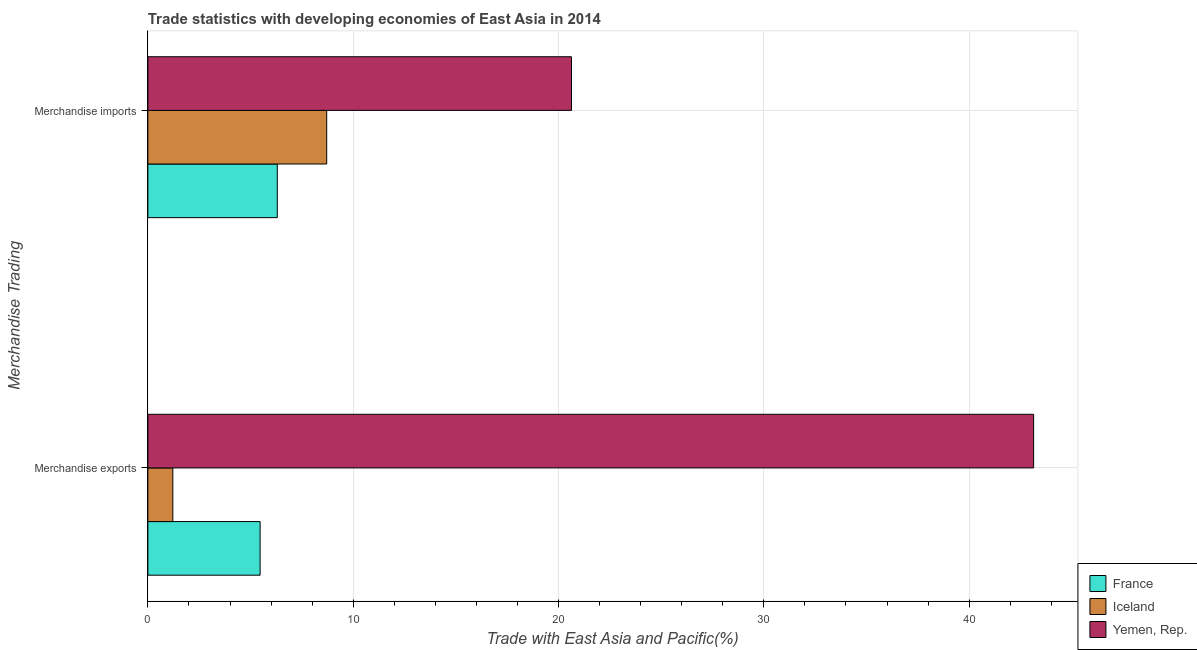Are the number of bars on each tick of the Y-axis equal?
Offer a terse response. Yes. How many bars are there on the 2nd tick from the top?
Give a very brief answer. 3. What is the merchandise imports in France?
Your answer should be compact. 6.3. Across all countries, what is the maximum merchandise imports?
Give a very brief answer. 20.63. Across all countries, what is the minimum merchandise exports?
Your answer should be very brief. 1.21. In which country was the merchandise imports maximum?
Give a very brief answer. Yemen, Rep. What is the total merchandise imports in the graph?
Offer a very short reply. 35.64. What is the difference between the merchandise imports in France and that in Yemen, Rep.?
Your answer should be compact. -14.33. What is the difference between the merchandise imports in France and the merchandise exports in Yemen, Rep.?
Your answer should be compact. -36.84. What is the average merchandise imports per country?
Your answer should be compact. 11.88. What is the difference between the merchandise exports and merchandise imports in Iceland?
Give a very brief answer. -7.49. What is the ratio of the merchandise exports in France to that in Yemen, Rep.?
Your answer should be very brief. 0.13. Is the merchandise imports in France less than that in Yemen, Rep.?
Make the answer very short. Yes. In how many countries, is the merchandise imports greater than the average merchandise imports taken over all countries?
Your answer should be compact. 1. What does the 1st bar from the top in Merchandise imports represents?
Offer a terse response. Yemen, Rep. What does the 2nd bar from the bottom in Merchandise imports represents?
Your answer should be compact. Iceland. How many countries are there in the graph?
Keep it short and to the point. 3. Where does the legend appear in the graph?
Provide a succinct answer. Bottom right. How are the legend labels stacked?
Your answer should be compact. Vertical. What is the title of the graph?
Provide a short and direct response. Trade statistics with developing economies of East Asia in 2014. Does "Grenada" appear as one of the legend labels in the graph?
Offer a terse response. No. What is the label or title of the X-axis?
Give a very brief answer. Trade with East Asia and Pacific(%). What is the label or title of the Y-axis?
Provide a short and direct response. Merchandise Trading. What is the Trade with East Asia and Pacific(%) of France in Merchandise exports?
Your response must be concise. 5.47. What is the Trade with East Asia and Pacific(%) in Iceland in Merchandise exports?
Your answer should be very brief. 1.21. What is the Trade with East Asia and Pacific(%) in Yemen, Rep. in Merchandise exports?
Provide a succinct answer. 43.14. What is the Trade with East Asia and Pacific(%) in France in Merchandise imports?
Your answer should be very brief. 6.3. What is the Trade with East Asia and Pacific(%) in Iceland in Merchandise imports?
Your answer should be compact. 8.71. What is the Trade with East Asia and Pacific(%) in Yemen, Rep. in Merchandise imports?
Provide a short and direct response. 20.63. Across all Merchandise Trading, what is the maximum Trade with East Asia and Pacific(%) of France?
Offer a terse response. 6.3. Across all Merchandise Trading, what is the maximum Trade with East Asia and Pacific(%) in Iceland?
Ensure brevity in your answer.  8.71. Across all Merchandise Trading, what is the maximum Trade with East Asia and Pacific(%) in Yemen, Rep.?
Provide a succinct answer. 43.14. Across all Merchandise Trading, what is the minimum Trade with East Asia and Pacific(%) in France?
Ensure brevity in your answer.  5.47. Across all Merchandise Trading, what is the minimum Trade with East Asia and Pacific(%) in Iceland?
Ensure brevity in your answer.  1.21. Across all Merchandise Trading, what is the minimum Trade with East Asia and Pacific(%) of Yemen, Rep.?
Offer a terse response. 20.63. What is the total Trade with East Asia and Pacific(%) in France in the graph?
Your answer should be very brief. 11.77. What is the total Trade with East Asia and Pacific(%) in Iceland in the graph?
Your response must be concise. 9.92. What is the total Trade with East Asia and Pacific(%) of Yemen, Rep. in the graph?
Your answer should be compact. 63.77. What is the difference between the Trade with East Asia and Pacific(%) in France in Merchandise exports and that in Merchandise imports?
Ensure brevity in your answer.  -0.84. What is the difference between the Trade with East Asia and Pacific(%) of Iceland in Merchandise exports and that in Merchandise imports?
Your answer should be very brief. -7.49. What is the difference between the Trade with East Asia and Pacific(%) in Yemen, Rep. in Merchandise exports and that in Merchandise imports?
Your answer should be compact. 22.51. What is the difference between the Trade with East Asia and Pacific(%) of France in Merchandise exports and the Trade with East Asia and Pacific(%) of Iceland in Merchandise imports?
Your answer should be very brief. -3.24. What is the difference between the Trade with East Asia and Pacific(%) in France in Merchandise exports and the Trade with East Asia and Pacific(%) in Yemen, Rep. in Merchandise imports?
Your response must be concise. -15.17. What is the difference between the Trade with East Asia and Pacific(%) of Iceland in Merchandise exports and the Trade with East Asia and Pacific(%) of Yemen, Rep. in Merchandise imports?
Your response must be concise. -19.42. What is the average Trade with East Asia and Pacific(%) of France per Merchandise Trading?
Your answer should be compact. 5.88. What is the average Trade with East Asia and Pacific(%) in Iceland per Merchandise Trading?
Provide a succinct answer. 4.96. What is the average Trade with East Asia and Pacific(%) of Yemen, Rep. per Merchandise Trading?
Ensure brevity in your answer.  31.89. What is the difference between the Trade with East Asia and Pacific(%) of France and Trade with East Asia and Pacific(%) of Iceland in Merchandise exports?
Your answer should be very brief. 4.25. What is the difference between the Trade with East Asia and Pacific(%) in France and Trade with East Asia and Pacific(%) in Yemen, Rep. in Merchandise exports?
Give a very brief answer. -37.67. What is the difference between the Trade with East Asia and Pacific(%) in Iceland and Trade with East Asia and Pacific(%) in Yemen, Rep. in Merchandise exports?
Give a very brief answer. -41.92. What is the difference between the Trade with East Asia and Pacific(%) of France and Trade with East Asia and Pacific(%) of Iceland in Merchandise imports?
Make the answer very short. -2.41. What is the difference between the Trade with East Asia and Pacific(%) of France and Trade with East Asia and Pacific(%) of Yemen, Rep. in Merchandise imports?
Your answer should be very brief. -14.33. What is the difference between the Trade with East Asia and Pacific(%) in Iceland and Trade with East Asia and Pacific(%) in Yemen, Rep. in Merchandise imports?
Keep it short and to the point. -11.92. What is the ratio of the Trade with East Asia and Pacific(%) in France in Merchandise exports to that in Merchandise imports?
Offer a terse response. 0.87. What is the ratio of the Trade with East Asia and Pacific(%) of Iceland in Merchandise exports to that in Merchandise imports?
Your answer should be compact. 0.14. What is the ratio of the Trade with East Asia and Pacific(%) of Yemen, Rep. in Merchandise exports to that in Merchandise imports?
Give a very brief answer. 2.09. What is the difference between the highest and the second highest Trade with East Asia and Pacific(%) of France?
Offer a terse response. 0.84. What is the difference between the highest and the second highest Trade with East Asia and Pacific(%) in Iceland?
Make the answer very short. 7.49. What is the difference between the highest and the second highest Trade with East Asia and Pacific(%) of Yemen, Rep.?
Provide a succinct answer. 22.51. What is the difference between the highest and the lowest Trade with East Asia and Pacific(%) of France?
Give a very brief answer. 0.84. What is the difference between the highest and the lowest Trade with East Asia and Pacific(%) in Iceland?
Make the answer very short. 7.49. What is the difference between the highest and the lowest Trade with East Asia and Pacific(%) of Yemen, Rep.?
Ensure brevity in your answer.  22.51. 